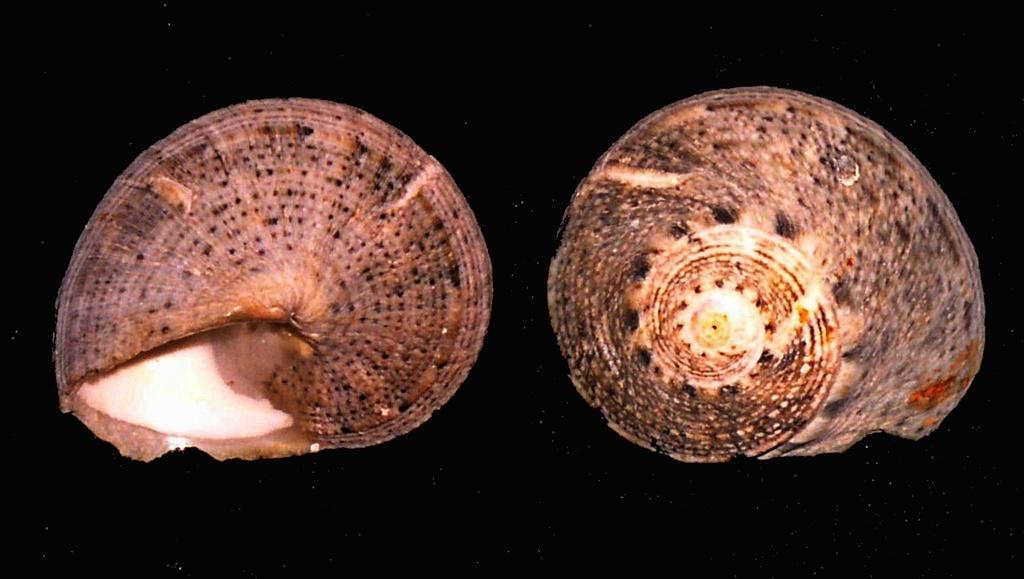In one or two sentences, can you explain what this image depicts? In this picture there are two snail shells and the background is in black color. 